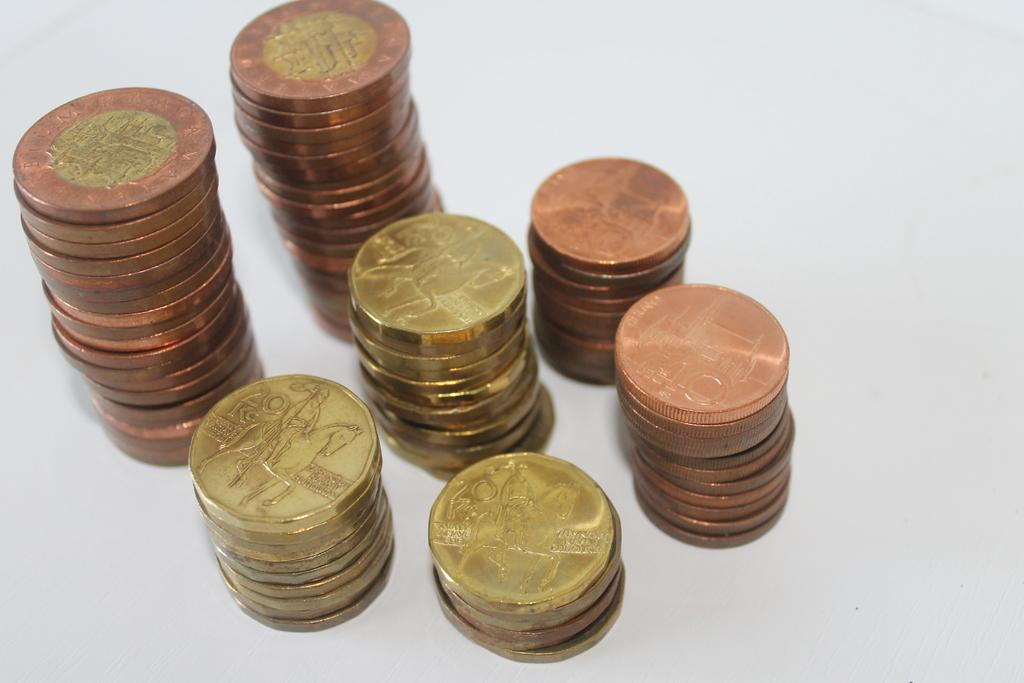<image>
Provide a brief description of the given image. A row of gold and copper coins that say 20 AD. 